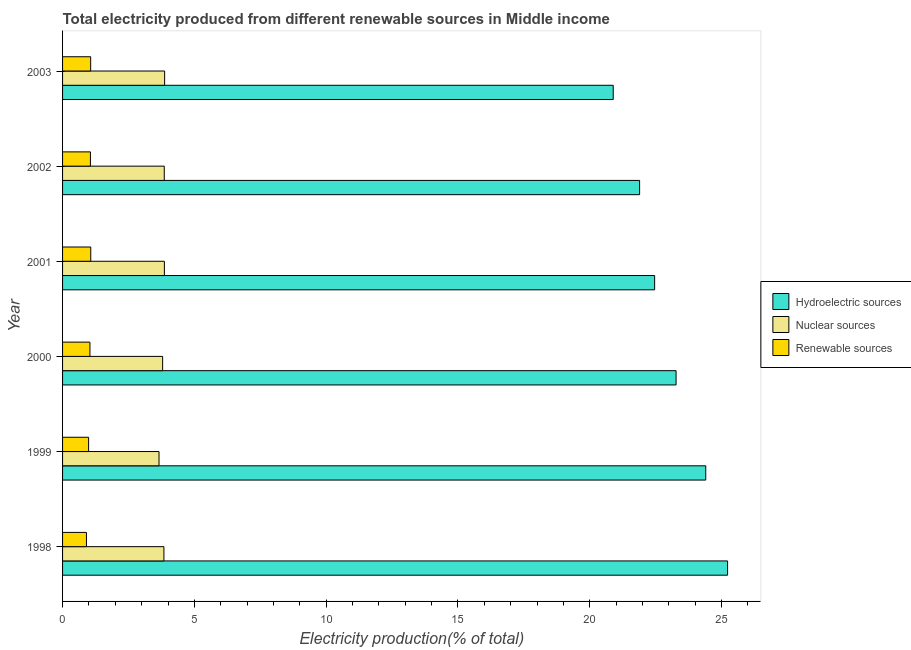How many different coloured bars are there?
Your answer should be very brief. 3. Are the number of bars per tick equal to the number of legend labels?
Your answer should be very brief. Yes. How many bars are there on the 1st tick from the top?
Give a very brief answer. 3. How many bars are there on the 2nd tick from the bottom?
Provide a short and direct response. 3. What is the label of the 1st group of bars from the top?
Ensure brevity in your answer.  2003. What is the percentage of electricity produced by nuclear sources in 1999?
Your answer should be compact. 3.66. Across all years, what is the maximum percentage of electricity produced by nuclear sources?
Keep it short and to the point. 3.87. Across all years, what is the minimum percentage of electricity produced by nuclear sources?
Your response must be concise. 3.66. What is the total percentage of electricity produced by hydroelectric sources in the graph?
Make the answer very short. 138.15. What is the difference between the percentage of electricity produced by renewable sources in 1998 and that in 2003?
Give a very brief answer. -0.16. What is the difference between the percentage of electricity produced by nuclear sources in 2003 and the percentage of electricity produced by hydroelectric sources in 1998?
Your answer should be very brief. -21.36. In the year 2001, what is the difference between the percentage of electricity produced by nuclear sources and percentage of electricity produced by hydroelectric sources?
Ensure brevity in your answer.  -18.6. In how many years, is the percentage of electricity produced by renewable sources greater than 6 %?
Offer a terse response. 0. What is the ratio of the percentage of electricity produced by renewable sources in 2001 to that in 2003?
Provide a short and direct response. 1. Is the percentage of electricity produced by renewable sources in 1998 less than that in 2000?
Your answer should be very brief. Yes. Is the difference between the percentage of electricity produced by nuclear sources in 1998 and 2000 greater than the difference between the percentage of electricity produced by renewable sources in 1998 and 2000?
Your answer should be compact. Yes. What is the difference between the highest and the second highest percentage of electricity produced by nuclear sources?
Keep it short and to the point. 0.01. What is the difference between the highest and the lowest percentage of electricity produced by hydroelectric sources?
Provide a succinct answer. 4.34. In how many years, is the percentage of electricity produced by renewable sources greater than the average percentage of electricity produced by renewable sources taken over all years?
Provide a short and direct response. 4. Is the sum of the percentage of electricity produced by renewable sources in 1998 and 2003 greater than the maximum percentage of electricity produced by nuclear sources across all years?
Your answer should be compact. No. What does the 2nd bar from the top in 1998 represents?
Provide a succinct answer. Nuclear sources. What does the 1st bar from the bottom in 2002 represents?
Your answer should be very brief. Hydroelectric sources. Is it the case that in every year, the sum of the percentage of electricity produced by hydroelectric sources and percentage of electricity produced by nuclear sources is greater than the percentage of electricity produced by renewable sources?
Your response must be concise. Yes. How many bars are there?
Offer a very short reply. 18. How many years are there in the graph?
Offer a very short reply. 6. Are the values on the major ticks of X-axis written in scientific E-notation?
Make the answer very short. No. Does the graph contain grids?
Provide a succinct answer. No. How are the legend labels stacked?
Your answer should be very brief. Vertical. What is the title of the graph?
Offer a terse response. Total electricity produced from different renewable sources in Middle income. What is the label or title of the X-axis?
Your response must be concise. Electricity production(% of total). What is the label or title of the Y-axis?
Your answer should be very brief. Year. What is the Electricity production(% of total) of Hydroelectric sources in 1998?
Give a very brief answer. 25.23. What is the Electricity production(% of total) of Nuclear sources in 1998?
Provide a succinct answer. 3.85. What is the Electricity production(% of total) of Renewable sources in 1998?
Make the answer very short. 0.91. What is the Electricity production(% of total) in Hydroelectric sources in 1999?
Provide a short and direct response. 24.4. What is the Electricity production(% of total) in Nuclear sources in 1999?
Offer a terse response. 3.66. What is the Electricity production(% of total) of Renewable sources in 1999?
Offer a very short reply. 0.99. What is the Electricity production(% of total) in Hydroelectric sources in 2000?
Give a very brief answer. 23.28. What is the Electricity production(% of total) of Nuclear sources in 2000?
Your answer should be compact. 3.8. What is the Electricity production(% of total) of Renewable sources in 2000?
Make the answer very short. 1.04. What is the Electricity production(% of total) in Hydroelectric sources in 2001?
Ensure brevity in your answer.  22.46. What is the Electricity production(% of total) of Nuclear sources in 2001?
Your answer should be compact. 3.86. What is the Electricity production(% of total) of Renewable sources in 2001?
Make the answer very short. 1.07. What is the Electricity production(% of total) of Hydroelectric sources in 2002?
Provide a short and direct response. 21.89. What is the Electricity production(% of total) in Nuclear sources in 2002?
Offer a very short reply. 3.86. What is the Electricity production(% of total) in Renewable sources in 2002?
Give a very brief answer. 1.06. What is the Electricity production(% of total) in Hydroelectric sources in 2003?
Your answer should be compact. 20.89. What is the Electricity production(% of total) of Nuclear sources in 2003?
Offer a very short reply. 3.87. What is the Electricity production(% of total) in Renewable sources in 2003?
Ensure brevity in your answer.  1.07. Across all years, what is the maximum Electricity production(% of total) in Hydroelectric sources?
Your answer should be very brief. 25.23. Across all years, what is the maximum Electricity production(% of total) in Nuclear sources?
Provide a succinct answer. 3.87. Across all years, what is the maximum Electricity production(% of total) in Renewable sources?
Make the answer very short. 1.07. Across all years, what is the minimum Electricity production(% of total) in Hydroelectric sources?
Your answer should be compact. 20.89. Across all years, what is the minimum Electricity production(% of total) in Nuclear sources?
Provide a short and direct response. 3.66. Across all years, what is the minimum Electricity production(% of total) in Renewable sources?
Provide a succinct answer. 0.91. What is the total Electricity production(% of total) of Hydroelectric sources in the graph?
Provide a short and direct response. 138.15. What is the total Electricity production(% of total) of Nuclear sources in the graph?
Keep it short and to the point. 22.89. What is the total Electricity production(% of total) of Renewable sources in the graph?
Your response must be concise. 6.12. What is the difference between the Electricity production(% of total) in Hydroelectric sources in 1998 and that in 1999?
Keep it short and to the point. 0.83. What is the difference between the Electricity production(% of total) in Nuclear sources in 1998 and that in 1999?
Offer a terse response. 0.19. What is the difference between the Electricity production(% of total) in Renewable sources in 1998 and that in 1999?
Give a very brief answer. -0.08. What is the difference between the Electricity production(% of total) of Hydroelectric sources in 1998 and that in 2000?
Give a very brief answer. 1.95. What is the difference between the Electricity production(% of total) of Nuclear sources in 1998 and that in 2000?
Your answer should be compact. 0.05. What is the difference between the Electricity production(% of total) of Renewable sources in 1998 and that in 2000?
Ensure brevity in your answer.  -0.13. What is the difference between the Electricity production(% of total) in Hydroelectric sources in 1998 and that in 2001?
Offer a terse response. 2.77. What is the difference between the Electricity production(% of total) in Nuclear sources in 1998 and that in 2001?
Your answer should be very brief. -0.02. What is the difference between the Electricity production(% of total) in Renewable sources in 1998 and that in 2001?
Make the answer very short. -0.16. What is the difference between the Electricity production(% of total) in Hydroelectric sources in 1998 and that in 2002?
Give a very brief answer. 3.34. What is the difference between the Electricity production(% of total) in Nuclear sources in 1998 and that in 2002?
Give a very brief answer. -0.01. What is the difference between the Electricity production(% of total) of Renewable sources in 1998 and that in 2002?
Your response must be concise. -0.15. What is the difference between the Electricity production(% of total) in Hydroelectric sources in 1998 and that in 2003?
Your answer should be very brief. 4.34. What is the difference between the Electricity production(% of total) of Nuclear sources in 1998 and that in 2003?
Offer a very short reply. -0.03. What is the difference between the Electricity production(% of total) of Renewable sources in 1998 and that in 2003?
Keep it short and to the point. -0.16. What is the difference between the Electricity production(% of total) in Hydroelectric sources in 1999 and that in 2000?
Keep it short and to the point. 1.13. What is the difference between the Electricity production(% of total) of Nuclear sources in 1999 and that in 2000?
Offer a very short reply. -0.14. What is the difference between the Electricity production(% of total) in Renewable sources in 1999 and that in 2000?
Your answer should be very brief. -0.05. What is the difference between the Electricity production(% of total) of Hydroelectric sources in 1999 and that in 2001?
Ensure brevity in your answer.  1.94. What is the difference between the Electricity production(% of total) in Nuclear sources in 1999 and that in 2001?
Your response must be concise. -0.2. What is the difference between the Electricity production(% of total) of Renewable sources in 1999 and that in 2001?
Provide a short and direct response. -0.08. What is the difference between the Electricity production(% of total) of Hydroelectric sources in 1999 and that in 2002?
Ensure brevity in your answer.  2.51. What is the difference between the Electricity production(% of total) of Nuclear sources in 1999 and that in 2002?
Offer a very short reply. -0.2. What is the difference between the Electricity production(% of total) of Renewable sources in 1999 and that in 2002?
Your answer should be compact. -0.07. What is the difference between the Electricity production(% of total) of Hydroelectric sources in 1999 and that in 2003?
Your answer should be compact. 3.51. What is the difference between the Electricity production(% of total) of Nuclear sources in 1999 and that in 2003?
Your answer should be compact. -0.21. What is the difference between the Electricity production(% of total) in Renewable sources in 1999 and that in 2003?
Ensure brevity in your answer.  -0.08. What is the difference between the Electricity production(% of total) of Hydroelectric sources in 2000 and that in 2001?
Provide a succinct answer. 0.81. What is the difference between the Electricity production(% of total) of Nuclear sources in 2000 and that in 2001?
Make the answer very short. -0.07. What is the difference between the Electricity production(% of total) of Renewable sources in 2000 and that in 2001?
Offer a very short reply. -0.03. What is the difference between the Electricity production(% of total) of Hydroelectric sources in 2000 and that in 2002?
Provide a succinct answer. 1.38. What is the difference between the Electricity production(% of total) in Nuclear sources in 2000 and that in 2002?
Your response must be concise. -0.06. What is the difference between the Electricity production(% of total) in Renewable sources in 2000 and that in 2002?
Your answer should be compact. -0.02. What is the difference between the Electricity production(% of total) of Hydroelectric sources in 2000 and that in 2003?
Give a very brief answer. 2.38. What is the difference between the Electricity production(% of total) of Nuclear sources in 2000 and that in 2003?
Offer a very short reply. -0.08. What is the difference between the Electricity production(% of total) in Renewable sources in 2000 and that in 2003?
Provide a succinct answer. -0.03. What is the difference between the Electricity production(% of total) in Hydroelectric sources in 2001 and that in 2002?
Offer a terse response. 0.57. What is the difference between the Electricity production(% of total) in Nuclear sources in 2001 and that in 2002?
Your answer should be very brief. 0. What is the difference between the Electricity production(% of total) in Renewable sources in 2001 and that in 2002?
Provide a succinct answer. 0.01. What is the difference between the Electricity production(% of total) of Hydroelectric sources in 2001 and that in 2003?
Your answer should be compact. 1.57. What is the difference between the Electricity production(% of total) of Nuclear sources in 2001 and that in 2003?
Give a very brief answer. -0.01. What is the difference between the Electricity production(% of total) in Renewable sources in 2001 and that in 2003?
Your answer should be compact. 0. What is the difference between the Electricity production(% of total) of Hydroelectric sources in 2002 and that in 2003?
Keep it short and to the point. 1. What is the difference between the Electricity production(% of total) of Nuclear sources in 2002 and that in 2003?
Your answer should be very brief. -0.01. What is the difference between the Electricity production(% of total) of Renewable sources in 2002 and that in 2003?
Your answer should be very brief. -0.01. What is the difference between the Electricity production(% of total) in Hydroelectric sources in 1998 and the Electricity production(% of total) in Nuclear sources in 1999?
Your answer should be very brief. 21.57. What is the difference between the Electricity production(% of total) in Hydroelectric sources in 1998 and the Electricity production(% of total) in Renewable sources in 1999?
Offer a very short reply. 24.24. What is the difference between the Electricity production(% of total) in Nuclear sources in 1998 and the Electricity production(% of total) in Renewable sources in 1999?
Make the answer very short. 2.86. What is the difference between the Electricity production(% of total) of Hydroelectric sources in 1998 and the Electricity production(% of total) of Nuclear sources in 2000?
Offer a terse response. 21.43. What is the difference between the Electricity production(% of total) of Hydroelectric sources in 1998 and the Electricity production(% of total) of Renewable sources in 2000?
Your response must be concise. 24.19. What is the difference between the Electricity production(% of total) in Nuclear sources in 1998 and the Electricity production(% of total) in Renewable sources in 2000?
Provide a short and direct response. 2.81. What is the difference between the Electricity production(% of total) of Hydroelectric sources in 1998 and the Electricity production(% of total) of Nuclear sources in 2001?
Make the answer very short. 21.37. What is the difference between the Electricity production(% of total) of Hydroelectric sources in 1998 and the Electricity production(% of total) of Renewable sources in 2001?
Offer a terse response. 24.16. What is the difference between the Electricity production(% of total) in Nuclear sources in 1998 and the Electricity production(% of total) in Renewable sources in 2001?
Make the answer very short. 2.78. What is the difference between the Electricity production(% of total) in Hydroelectric sources in 1998 and the Electricity production(% of total) in Nuclear sources in 2002?
Your answer should be very brief. 21.37. What is the difference between the Electricity production(% of total) in Hydroelectric sources in 1998 and the Electricity production(% of total) in Renewable sources in 2002?
Provide a succinct answer. 24.17. What is the difference between the Electricity production(% of total) of Nuclear sources in 1998 and the Electricity production(% of total) of Renewable sources in 2002?
Offer a very short reply. 2.79. What is the difference between the Electricity production(% of total) in Hydroelectric sources in 1998 and the Electricity production(% of total) in Nuclear sources in 2003?
Your response must be concise. 21.36. What is the difference between the Electricity production(% of total) in Hydroelectric sources in 1998 and the Electricity production(% of total) in Renewable sources in 2003?
Your answer should be compact. 24.16. What is the difference between the Electricity production(% of total) of Nuclear sources in 1998 and the Electricity production(% of total) of Renewable sources in 2003?
Provide a short and direct response. 2.78. What is the difference between the Electricity production(% of total) of Hydroelectric sources in 1999 and the Electricity production(% of total) of Nuclear sources in 2000?
Ensure brevity in your answer.  20.6. What is the difference between the Electricity production(% of total) of Hydroelectric sources in 1999 and the Electricity production(% of total) of Renewable sources in 2000?
Your response must be concise. 23.36. What is the difference between the Electricity production(% of total) in Nuclear sources in 1999 and the Electricity production(% of total) in Renewable sources in 2000?
Provide a succinct answer. 2.62. What is the difference between the Electricity production(% of total) in Hydroelectric sources in 1999 and the Electricity production(% of total) in Nuclear sources in 2001?
Offer a terse response. 20.54. What is the difference between the Electricity production(% of total) of Hydroelectric sources in 1999 and the Electricity production(% of total) of Renewable sources in 2001?
Offer a very short reply. 23.33. What is the difference between the Electricity production(% of total) in Nuclear sources in 1999 and the Electricity production(% of total) in Renewable sources in 2001?
Keep it short and to the point. 2.59. What is the difference between the Electricity production(% of total) of Hydroelectric sources in 1999 and the Electricity production(% of total) of Nuclear sources in 2002?
Make the answer very short. 20.54. What is the difference between the Electricity production(% of total) of Hydroelectric sources in 1999 and the Electricity production(% of total) of Renewable sources in 2002?
Your response must be concise. 23.34. What is the difference between the Electricity production(% of total) of Nuclear sources in 1999 and the Electricity production(% of total) of Renewable sources in 2002?
Ensure brevity in your answer.  2.6. What is the difference between the Electricity production(% of total) in Hydroelectric sources in 1999 and the Electricity production(% of total) in Nuclear sources in 2003?
Your response must be concise. 20.53. What is the difference between the Electricity production(% of total) in Hydroelectric sources in 1999 and the Electricity production(% of total) in Renewable sources in 2003?
Your answer should be very brief. 23.33. What is the difference between the Electricity production(% of total) in Nuclear sources in 1999 and the Electricity production(% of total) in Renewable sources in 2003?
Your answer should be compact. 2.59. What is the difference between the Electricity production(% of total) of Hydroelectric sources in 2000 and the Electricity production(% of total) of Nuclear sources in 2001?
Your answer should be compact. 19.41. What is the difference between the Electricity production(% of total) in Hydroelectric sources in 2000 and the Electricity production(% of total) in Renewable sources in 2001?
Give a very brief answer. 22.21. What is the difference between the Electricity production(% of total) in Nuclear sources in 2000 and the Electricity production(% of total) in Renewable sources in 2001?
Provide a short and direct response. 2.73. What is the difference between the Electricity production(% of total) of Hydroelectric sources in 2000 and the Electricity production(% of total) of Nuclear sources in 2002?
Offer a very short reply. 19.42. What is the difference between the Electricity production(% of total) in Hydroelectric sources in 2000 and the Electricity production(% of total) in Renewable sources in 2002?
Give a very brief answer. 22.22. What is the difference between the Electricity production(% of total) of Nuclear sources in 2000 and the Electricity production(% of total) of Renewable sources in 2002?
Provide a succinct answer. 2.74. What is the difference between the Electricity production(% of total) of Hydroelectric sources in 2000 and the Electricity production(% of total) of Nuclear sources in 2003?
Your answer should be compact. 19.4. What is the difference between the Electricity production(% of total) in Hydroelectric sources in 2000 and the Electricity production(% of total) in Renewable sources in 2003?
Offer a terse response. 22.21. What is the difference between the Electricity production(% of total) of Nuclear sources in 2000 and the Electricity production(% of total) of Renewable sources in 2003?
Provide a succinct answer. 2.73. What is the difference between the Electricity production(% of total) in Hydroelectric sources in 2001 and the Electricity production(% of total) in Nuclear sources in 2002?
Offer a very short reply. 18.6. What is the difference between the Electricity production(% of total) of Hydroelectric sources in 2001 and the Electricity production(% of total) of Renewable sources in 2002?
Make the answer very short. 21.41. What is the difference between the Electricity production(% of total) of Nuclear sources in 2001 and the Electricity production(% of total) of Renewable sources in 2002?
Ensure brevity in your answer.  2.81. What is the difference between the Electricity production(% of total) of Hydroelectric sources in 2001 and the Electricity production(% of total) of Nuclear sources in 2003?
Keep it short and to the point. 18.59. What is the difference between the Electricity production(% of total) of Hydroelectric sources in 2001 and the Electricity production(% of total) of Renewable sources in 2003?
Provide a succinct answer. 21.4. What is the difference between the Electricity production(% of total) of Nuclear sources in 2001 and the Electricity production(% of total) of Renewable sources in 2003?
Ensure brevity in your answer.  2.8. What is the difference between the Electricity production(% of total) in Hydroelectric sources in 2002 and the Electricity production(% of total) in Nuclear sources in 2003?
Ensure brevity in your answer.  18.02. What is the difference between the Electricity production(% of total) of Hydroelectric sources in 2002 and the Electricity production(% of total) of Renewable sources in 2003?
Provide a succinct answer. 20.83. What is the difference between the Electricity production(% of total) in Nuclear sources in 2002 and the Electricity production(% of total) in Renewable sources in 2003?
Offer a very short reply. 2.79. What is the average Electricity production(% of total) of Hydroelectric sources per year?
Keep it short and to the point. 23.02. What is the average Electricity production(% of total) in Nuclear sources per year?
Keep it short and to the point. 3.82. What is the average Electricity production(% of total) of Renewable sources per year?
Ensure brevity in your answer.  1.02. In the year 1998, what is the difference between the Electricity production(% of total) in Hydroelectric sources and Electricity production(% of total) in Nuclear sources?
Ensure brevity in your answer.  21.38. In the year 1998, what is the difference between the Electricity production(% of total) of Hydroelectric sources and Electricity production(% of total) of Renewable sources?
Offer a very short reply. 24.32. In the year 1998, what is the difference between the Electricity production(% of total) of Nuclear sources and Electricity production(% of total) of Renewable sources?
Provide a short and direct response. 2.94. In the year 1999, what is the difference between the Electricity production(% of total) of Hydroelectric sources and Electricity production(% of total) of Nuclear sources?
Offer a very short reply. 20.74. In the year 1999, what is the difference between the Electricity production(% of total) in Hydroelectric sources and Electricity production(% of total) in Renewable sources?
Ensure brevity in your answer.  23.41. In the year 1999, what is the difference between the Electricity production(% of total) in Nuclear sources and Electricity production(% of total) in Renewable sources?
Your response must be concise. 2.67. In the year 2000, what is the difference between the Electricity production(% of total) of Hydroelectric sources and Electricity production(% of total) of Nuclear sources?
Offer a very short reply. 19.48. In the year 2000, what is the difference between the Electricity production(% of total) in Hydroelectric sources and Electricity production(% of total) in Renewable sources?
Your answer should be very brief. 22.24. In the year 2000, what is the difference between the Electricity production(% of total) of Nuclear sources and Electricity production(% of total) of Renewable sources?
Provide a short and direct response. 2.76. In the year 2001, what is the difference between the Electricity production(% of total) in Hydroelectric sources and Electricity production(% of total) in Nuclear sources?
Provide a succinct answer. 18.6. In the year 2001, what is the difference between the Electricity production(% of total) of Hydroelectric sources and Electricity production(% of total) of Renewable sources?
Offer a very short reply. 21.39. In the year 2001, what is the difference between the Electricity production(% of total) of Nuclear sources and Electricity production(% of total) of Renewable sources?
Make the answer very short. 2.79. In the year 2002, what is the difference between the Electricity production(% of total) in Hydroelectric sources and Electricity production(% of total) in Nuclear sources?
Offer a very short reply. 18.03. In the year 2002, what is the difference between the Electricity production(% of total) of Hydroelectric sources and Electricity production(% of total) of Renewable sources?
Your answer should be very brief. 20.83. In the year 2002, what is the difference between the Electricity production(% of total) of Nuclear sources and Electricity production(% of total) of Renewable sources?
Your answer should be very brief. 2.8. In the year 2003, what is the difference between the Electricity production(% of total) in Hydroelectric sources and Electricity production(% of total) in Nuclear sources?
Ensure brevity in your answer.  17.02. In the year 2003, what is the difference between the Electricity production(% of total) of Hydroelectric sources and Electricity production(% of total) of Renewable sources?
Provide a short and direct response. 19.82. In the year 2003, what is the difference between the Electricity production(% of total) in Nuclear sources and Electricity production(% of total) in Renewable sources?
Ensure brevity in your answer.  2.81. What is the ratio of the Electricity production(% of total) in Hydroelectric sources in 1998 to that in 1999?
Offer a terse response. 1.03. What is the ratio of the Electricity production(% of total) in Nuclear sources in 1998 to that in 1999?
Give a very brief answer. 1.05. What is the ratio of the Electricity production(% of total) of Renewable sources in 1998 to that in 1999?
Provide a succinct answer. 0.92. What is the ratio of the Electricity production(% of total) in Hydroelectric sources in 1998 to that in 2000?
Ensure brevity in your answer.  1.08. What is the ratio of the Electricity production(% of total) in Nuclear sources in 1998 to that in 2000?
Give a very brief answer. 1.01. What is the ratio of the Electricity production(% of total) in Renewable sources in 1998 to that in 2000?
Offer a very short reply. 0.87. What is the ratio of the Electricity production(% of total) of Hydroelectric sources in 1998 to that in 2001?
Keep it short and to the point. 1.12. What is the ratio of the Electricity production(% of total) in Nuclear sources in 1998 to that in 2001?
Your answer should be very brief. 1. What is the ratio of the Electricity production(% of total) in Renewable sources in 1998 to that in 2001?
Offer a terse response. 0.85. What is the ratio of the Electricity production(% of total) of Hydroelectric sources in 1998 to that in 2002?
Keep it short and to the point. 1.15. What is the ratio of the Electricity production(% of total) in Nuclear sources in 1998 to that in 2002?
Provide a short and direct response. 1. What is the ratio of the Electricity production(% of total) in Renewable sources in 1998 to that in 2002?
Make the answer very short. 0.86. What is the ratio of the Electricity production(% of total) of Hydroelectric sources in 1998 to that in 2003?
Your answer should be compact. 1.21. What is the ratio of the Electricity production(% of total) of Renewable sources in 1998 to that in 2003?
Make the answer very short. 0.85. What is the ratio of the Electricity production(% of total) in Hydroelectric sources in 1999 to that in 2000?
Your answer should be compact. 1.05. What is the ratio of the Electricity production(% of total) in Nuclear sources in 1999 to that in 2000?
Your answer should be compact. 0.96. What is the ratio of the Electricity production(% of total) in Renewable sources in 1999 to that in 2000?
Give a very brief answer. 0.95. What is the ratio of the Electricity production(% of total) in Hydroelectric sources in 1999 to that in 2001?
Your answer should be compact. 1.09. What is the ratio of the Electricity production(% of total) of Nuclear sources in 1999 to that in 2001?
Your answer should be very brief. 0.95. What is the ratio of the Electricity production(% of total) in Renewable sources in 1999 to that in 2001?
Offer a very short reply. 0.92. What is the ratio of the Electricity production(% of total) in Hydroelectric sources in 1999 to that in 2002?
Your response must be concise. 1.11. What is the ratio of the Electricity production(% of total) of Nuclear sources in 1999 to that in 2002?
Provide a short and direct response. 0.95. What is the ratio of the Electricity production(% of total) of Renewable sources in 1999 to that in 2002?
Provide a succinct answer. 0.94. What is the ratio of the Electricity production(% of total) in Hydroelectric sources in 1999 to that in 2003?
Give a very brief answer. 1.17. What is the ratio of the Electricity production(% of total) in Nuclear sources in 1999 to that in 2003?
Your response must be concise. 0.95. What is the ratio of the Electricity production(% of total) of Renewable sources in 1999 to that in 2003?
Ensure brevity in your answer.  0.93. What is the ratio of the Electricity production(% of total) of Hydroelectric sources in 2000 to that in 2001?
Your answer should be very brief. 1.04. What is the ratio of the Electricity production(% of total) of Nuclear sources in 2000 to that in 2001?
Make the answer very short. 0.98. What is the ratio of the Electricity production(% of total) of Renewable sources in 2000 to that in 2001?
Give a very brief answer. 0.97. What is the ratio of the Electricity production(% of total) in Hydroelectric sources in 2000 to that in 2002?
Provide a succinct answer. 1.06. What is the ratio of the Electricity production(% of total) in Nuclear sources in 2000 to that in 2002?
Offer a terse response. 0.98. What is the ratio of the Electricity production(% of total) in Renewable sources in 2000 to that in 2002?
Make the answer very short. 0.98. What is the ratio of the Electricity production(% of total) of Hydroelectric sources in 2000 to that in 2003?
Offer a very short reply. 1.11. What is the ratio of the Electricity production(% of total) of Nuclear sources in 2000 to that in 2003?
Make the answer very short. 0.98. What is the ratio of the Electricity production(% of total) of Renewable sources in 2000 to that in 2003?
Ensure brevity in your answer.  0.97. What is the ratio of the Electricity production(% of total) of Nuclear sources in 2001 to that in 2002?
Offer a terse response. 1. What is the ratio of the Electricity production(% of total) in Renewable sources in 2001 to that in 2002?
Your answer should be compact. 1.01. What is the ratio of the Electricity production(% of total) of Hydroelectric sources in 2001 to that in 2003?
Your answer should be compact. 1.08. What is the ratio of the Electricity production(% of total) of Nuclear sources in 2001 to that in 2003?
Make the answer very short. 1. What is the ratio of the Electricity production(% of total) of Renewable sources in 2001 to that in 2003?
Give a very brief answer. 1. What is the ratio of the Electricity production(% of total) in Hydroelectric sources in 2002 to that in 2003?
Offer a terse response. 1.05. What is the ratio of the Electricity production(% of total) in Renewable sources in 2002 to that in 2003?
Ensure brevity in your answer.  0.99. What is the difference between the highest and the second highest Electricity production(% of total) in Hydroelectric sources?
Ensure brevity in your answer.  0.83. What is the difference between the highest and the second highest Electricity production(% of total) in Nuclear sources?
Your response must be concise. 0.01. What is the difference between the highest and the second highest Electricity production(% of total) of Renewable sources?
Provide a succinct answer. 0. What is the difference between the highest and the lowest Electricity production(% of total) of Hydroelectric sources?
Keep it short and to the point. 4.34. What is the difference between the highest and the lowest Electricity production(% of total) of Nuclear sources?
Keep it short and to the point. 0.21. What is the difference between the highest and the lowest Electricity production(% of total) of Renewable sources?
Make the answer very short. 0.16. 